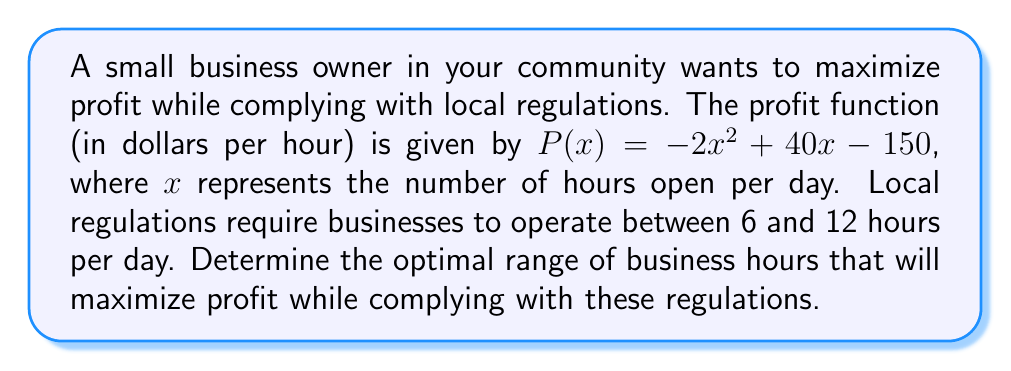Could you help me with this problem? 1. To find the optimal range, we need to determine the maximum of the profit function within the given constraints.

2. The profit function is a quadratic function: $P(x) = -2x^2 + 40x - 150$

3. To find the maximum, we calculate the vertex of the parabola:
   $x = -\frac{b}{2a} = -\frac{40}{2(-2)} = 10$

4. The vertex occurs at $x = 10$ hours, which is within the allowed range of 6 to 12 hours.

5. To verify this is a maximum (not a minimum), we check the coefficient of $x^2$:
   The coefficient is negative ($-2$), confirming this is a maximum.

6. Therefore, the optimal number of hours to maximize profit is 10 hours per day.

7. To comply with regulations, the business must operate between 6 and 12 hours:
   $6 \leq x \leq 12$

8. Since the optimal point (10 hours) falls within this range, the business can operate at maximum profit while complying with regulations.

9. The optimal range is thus $[6, 12]$ hours, with the most profitable point being 10 hours.
Answer: $[6, 12]$ hours, optimal at 10 hours 